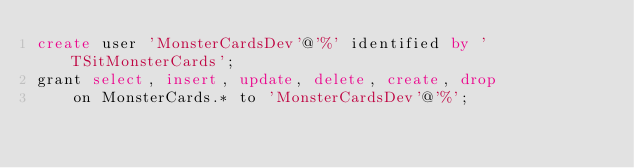Convert code to text. <code><loc_0><loc_0><loc_500><loc_500><_SQL_>create user 'MonsterCardsDev'@'%' identified by 'TSitMonsterCards';
grant select, insert, update, delete, create, drop
	on MonsterCards.* to 'MonsterCardsDev'@'%';</code> 